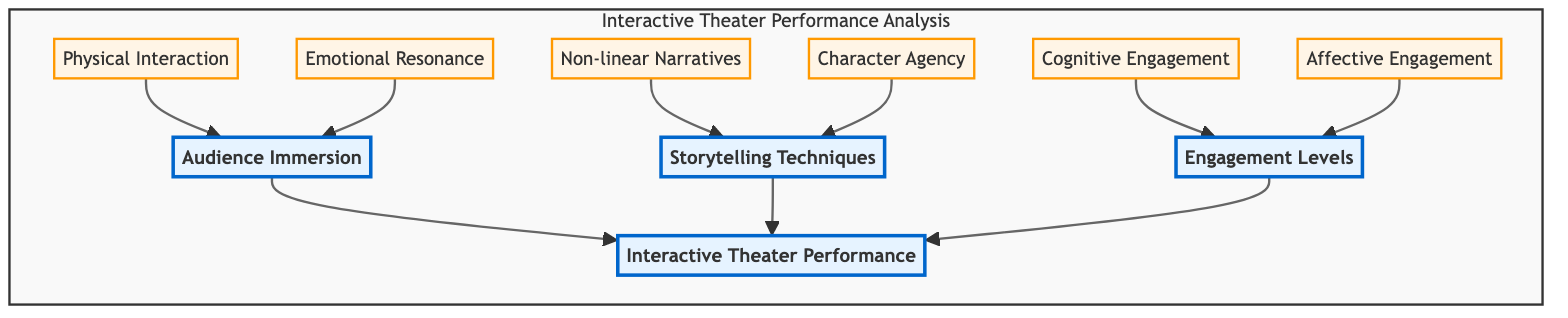What are the three main elements in the diagram? The diagram shows three main elements: Audience Immersion, Storytelling Techniques, and Engagement Levels. These are distinctly identified at the top of the flowchart as the primary nodes.
Answer: Audience Immersion, Storytelling Techniques, Engagement Levels How many sub-elements are listed under Audience Immersion? On the diagram, there are two sub-elements listed under Audience Immersion: Physical Interaction and Emotional Resonance. Both are connected directly to the Audience Immersion node.
Answer: 2 Which sub-element contributes to the Engagement Levels? The sub-elements contributing to Engagement Levels, as shown in the diagram, are Cognitive Engagement and Affective Engagement, both pointing to the Engagement Levels node.
Answer: Cognitive Engagement, Affective Engagement What storytelling technique allows audience choices to affect story outcomes? Non-linear Narratives is identified in the diagram as the storytelling technique where audience choices influence the progression and outcome of the narrative.
Answer: Non-linear Narratives What is the relationship between Physical Interaction and Audience Immersion? Physical Interaction is a sub-element directly connected to the Audience Immersion node, indicating that it contributes to the level of audience participation in the performance.
Answer: Contributes to How does Affective Engagement influence the overall performance? Affective Engagement, being a sub-element connected to Engagement Levels, implies that it plays a role in how emotionally connected the audience feels during the performance, which in turn affects their overall experience.
Answer: Influences emotionally What are the two dimensions of engagement assessed in the diagram? The diagram indicates two dimensions of engagement: Cognitive Engagement and Affective Engagement, as shown under the Engagement Levels node.
Answer: Cognitive Engagement, Affective Engagement Is Character Agency a sub-element of Audience Immersion? No, Character Agency is a sub-element of Storytelling Techniques, which is shown distinctly separate from Audience Immersion in the diagram's structure.
Answer: No What type of narrative technique is character influence utilized in? Character Agency is the technique where audience members can influence character decisions and arcs, as depicted in the storytelling techniques section of the diagram.
Answer: Character Agency 